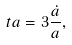<formula> <loc_0><loc_0><loc_500><loc_500>\ t a = 3 \frac { \dot { a } } { a } ,</formula> 